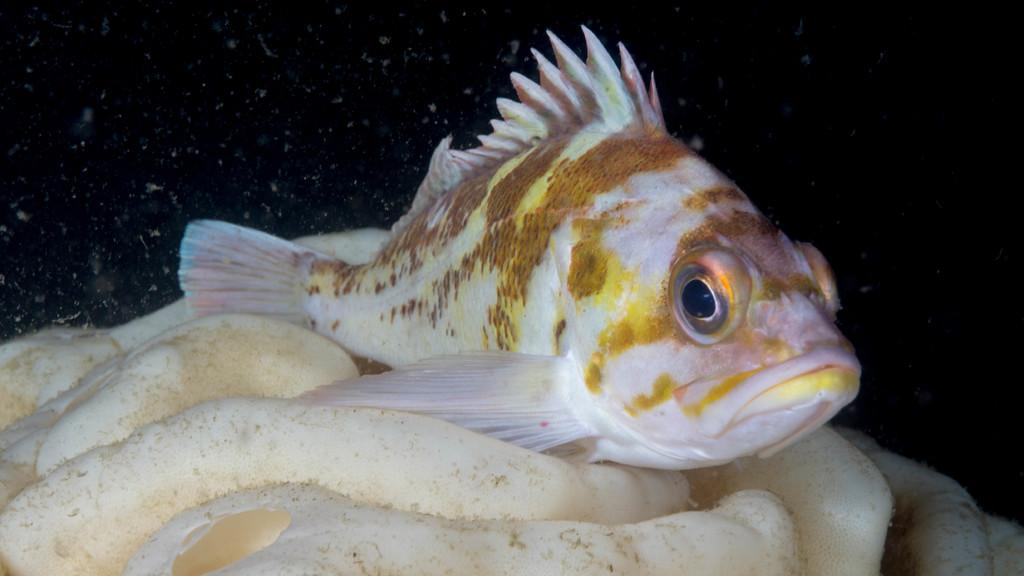What type of natural feature is present in the image? There is a water body in the image. Can you describe the fish in the image? There is a fish on a stone in the image. What is the annual income of the plantation owner in the image? There is no plantation or plantation owner present in the image, so it is not possible to determine their annual income. 